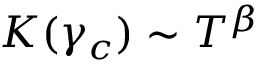Convert formula to latex. <formula><loc_0><loc_0><loc_500><loc_500>K ( \gamma _ { c } ) \sim T ^ { \beta }</formula> 